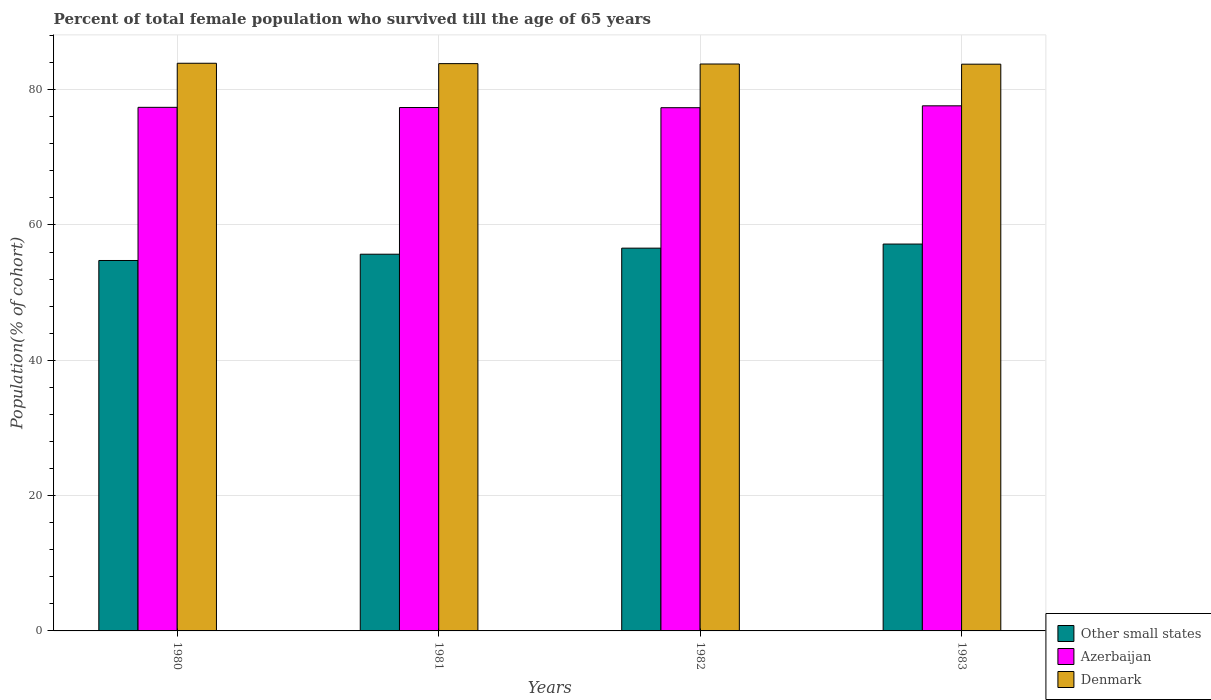How many groups of bars are there?
Ensure brevity in your answer.  4. Are the number of bars per tick equal to the number of legend labels?
Offer a very short reply. Yes. Are the number of bars on each tick of the X-axis equal?
Provide a succinct answer. Yes. How many bars are there on the 2nd tick from the left?
Provide a short and direct response. 3. How many bars are there on the 3rd tick from the right?
Provide a short and direct response. 3. In how many cases, is the number of bars for a given year not equal to the number of legend labels?
Provide a succinct answer. 0. What is the percentage of total female population who survived till the age of 65 years in Azerbaijan in 1982?
Make the answer very short. 77.33. Across all years, what is the maximum percentage of total female population who survived till the age of 65 years in Other small states?
Your answer should be compact. 57.17. Across all years, what is the minimum percentage of total female population who survived till the age of 65 years in Other small states?
Keep it short and to the point. 54.75. What is the total percentage of total female population who survived till the age of 65 years in Other small states in the graph?
Your response must be concise. 224.16. What is the difference between the percentage of total female population who survived till the age of 65 years in Denmark in 1981 and that in 1982?
Provide a succinct answer. 0.05. What is the difference between the percentage of total female population who survived till the age of 65 years in Other small states in 1982 and the percentage of total female population who survived till the age of 65 years in Azerbaijan in 1983?
Your answer should be very brief. -21.03. What is the average percentage of total female population who survived till the age of 65 years in Azerbaijan per year?
Give a very brief answer. 77.42. In the year 1983, what is the difference between the percentage of total female population who survived till the age of 65 years in Azerbaijan and percentage of total female population who survived till the age of 65 years in Denmark?
Your answer should be compact. -6.15. In how many years, is the percentage of total female population who survived till the age of 65 years in Denmark greater than 84 %?
Keep it short and to the point. 0. What is the ratio of the percentage of total female population who survived till the age of 65 years in Azerbaijan in 1980 to that in 1982?
Provide a short and direct response. 1. Is the difference between the percentage of total female population who survived till the age of 65 years in Azerbaijan in 1981 and 1983 greater than the difference between the percentage of total female population who survived till the age of 65 years in Denmark in 1981 and 1983?
Offer a very short reply. No. What is the difference between the highest and the second highest percentage of total female population who survived till the age of 65 years in Azerbaijan?
Your answer should be very brief. 0.22. What is the difference between the highest and the lowest percentage of total female population who survived till the age of 65 years in Azerbaijan?
Provide a short and direct response. 0.28. Is the sum of the percentage of total female population who survived till the age of 65 years in Denmark in 1981 and 1982 greater than the maximum percentage of total female population who survived till the age of 65 years in Azerbaijan across all years?
Offer a very short reply. Yes. What does the 2nd bar from the left in 1980 represents?
Offer a very short reply. Azerbaijan. What does the 1st bar from the right in 1980 represents?
Give a very brief answer. Denmark. Are all the bars in the graph horizontal?
Provide a succinct answer. No. How many years are there in the graph?
Keep it short and to the point. 4. Does the graph contain any zero values?
Your answer should be compact. No. What is the title of the graph?
Ensure brevity in your answer.  Percent of total female population who survived till the age of 65 years. What is the label or title of the Y-axis?
Your answer should be compact. Population(% of cohort). What is the Population(% of cohort) in Other small states in 1980?
Your answer should be very brief. 54.75. What is the Population(% of cohort) in Azerbaijan in 1980?
Give a very brief answer. 77.38. What is the Population(% of cohort) in Denmark in 1980?
Provide a succinct answer. 83.89. What is the Population(% of cohort) in Other small states in 1981?
Your response must be concise. 55.67. What is the Population(% of cohort) of Azerbaijan in 1981?
Provide a succinct answer. 77.35. What is the Population(% of cohort) of Denmark in 1981?
Ensure brevity in your answer.  83.84. What is the Population(% of cohort) in Other small states in 1982?
Your answer should be very brief. 56.57. What is the Population(% of cohort) in Azerbaijan in 1982?
Give a very brief answer. 77.33. What is the Population(% of cohort) of Denmark in 1982?
Your answer should be compact. 83.78. What is the Population(% of cohort) of Other small states in 1983?
Your answer should be very brief. 57.17. What is the Population(% of cohort) in Azerbaijan in 1983?
Your answer should be compact. 77.6. What is the Population(% of cohort) in Denmark in 1983?
Provide a succinct answer. 83.76. Across all years, what is the maximum Population(% of cohort) in Other small states?
Ensure brevity in your answer.  57.17. Across all years, what is the maximum Population(% of cohort) in Azerbaijan?
Offer a very short reply. 77.6. Across all years, what is the maximum Population(% of cohort) of Denmark?
Keep it short and to the point. 83.89. Across all years, what is the minimum Population(% of cohort) in Other small states?
Offer a very short reply. 54.75. Across all years, what is the minimum Population(% of cohort) of Azerbaijan?
Your answer should be compact. 77.33. Across all years, what is the minimum Population(% of cohort) of Denmark?
Your answer should be very brief. 83.76. What is the total Population(% of cohort) in Other small states in the graph?
Offer a terse response. 224.16. What is the total Population(% of cohort) of Azerbaijan in the graph?
Make the answer very short. 309.66. What is the total Population(% of cohort) in Denmark in the graph?
Ensure brevity in your answer.  335.27. What is the difference between the Population(% of cohort) of Other small states in 1980 and that in 1981?
Keep it short and to the point. -0.93. What is the difference between the Population(% of cohort) in Azerbaijan in 1980 and that in 1981?
Offer a very short reply. 0.03. What is the difference between the Population(% of cohort) of Denmark in 1980 and that in 1981?
Offer a very short reply. 0.06. What is the difference between the Population(% of cohort) of Other small states in 1980 and that in 1982?
Provide a short and direct response. -1.82. What is the difference between the Population(% of cohort) in Azerbaijan in 1980 and that in 1982?
Keep it short and to the point. 0.05. What is the difference between the Population(% of cohort) of Denmark in 1980 and that in 1982?
Ensure brevity in your answer.  0.11. What is the difference between the Population(% of cohort) of Other small states in 1980 and that in 1983?
Your answer should be very brief. -2.43. What is the difference between the Population(% of cohort) in Azerbaijan in 1980 and that in 1983?
Keep it short and to the point. -0.22. What is the difference between the Population(% of cohort) in Denmark in 1980 and that in 1983?
Provide a short and direct response. 0.14. What is the difference between the Population(% of cohort) of Other small states in 1981 and that in 1982?
Give a very brief answer. -0.9. What is the difference between the Population(% of cohort) in Azerbaijan in 1981 and that in 1982?
Your answer should be compact. 0.03. What is the difference between the Population(% of cohort) in Denmark in 1981 and that in 1982?
Provide a short and direct response. 0.06. What is the difference between the Population(% of cohort) in Other small states in 1981 and that in 1983?
Give a very brief answer. -1.5. What is the difference between the Population(% of cohort) of Azerbaijan in 1981 and that in 1983?
Your answer should be compact. -0.25. What is the difference between the Population(% of cohort) of Denmark in 1981 and that in 1983?
Your response must be concise. 0.08. What is the difference between the Population(% of cohort) of Other small states in 1982 and that in 1983?
Keep it short and to the point. -0.61. What is the difference between the Population(% of cohort) of Azerbaijan in 1982 and that in 1983?
Keep it short and to the point. -0.28. What is the difference between the Population(% of cohort) of Denmark in 1982 and that in 1983?
Your response must be concise. 0.03. What is the difference between the Population(% of cohort) of Other small states in 1980 and the Population(% of cohort) of Azerbaijan in 1981?
Your response must be concise. -22.61. What is the difference between the Population(% of cohort) in Other small states in 1980 and the Population(% of cohort) in Denmark in 1981?
Provide a succinct answer. -29.09. What is the difference between the Population(% of cohort) of Azerbaijan in 1980 and the Population(% of cohort) of Denmark in 1981?
Keep it short and to the point. -6.46. What is the difference between the Population(% of cohort) of Other small states in 1980 and the Population(% of cohort) of Azerbaijan in 1982?
Provide a succinct answer. -22.58. What is the difference between the Population(% of cohort) in Other small states in 1980 and the Population(% of cohort) in Denmark in 1982?
Make the answer very short. -29.04. What is the difference between the Population(% of cohort) in Azerbaijan in 1980 and the Population(% of cohort) in Denmark in 1982?
Provide a succinct answer. -6.4. What is the difference between the Population(% of cohort) in Other small states in 1980 and the Population(% of cohort) in Azerbaijan in 1983?
Offer a very short reply. -22.86. What is the difference between the Population(% of cohort) in Other small states in 1980 and the Population(% of cohort) in Denmark in 1983?
Keep it short and to the point. -29.01. What is the difference between the Population(% of cohort) of Azerbaijan in 1980 and the Population(% of cohort) of Denmark in 1983?
Offer a very short reply. -6.38. What is the difference between the Population(% of cohort) of Other small states in 1981 and the Population(% of cohort) of Azerbaijan in 1982?
Ensure brevity in your answer.  -21.65. What is the difference between the Population(% of cohort) in Other small states in 1981 and the Population(% of cohort) in Denmark in 1982?
Your answer should be compact. -28.11. What is the difference between the Population(% of cohort) in Azerbaijan in 1981 and the Population(% of cohort) in Denmark in 1982?
Keep it short and to the point. -6.43. What is the difference between the Population(% of cohort) in Other small states in 1981 and the Population(% of cohort) in Azerbaijan in 1983?
Provide a short and direct response. -21.93. What is the difference between the Population(% of cohort) in Other small states in 1981 and the Population(% of cohort) in Denmark in 1983?
Provide a short and direct response. -28.09. What is the difference between the Population(% of cohort) of Azerbaijan in 1981 and the Population(% of cohort) of Denmark in 1983?
Keep it short and to the point. -6.4. What is the difference between the Population(% of cohort) of Other small states in 1982 and the Population(% of cohort) of Azerbaijan in 1983?
Give a very brief answer. -21.03. What is the difference between the Population(% of cohort) in Other small states in 1982 and the Population(% of cohort) in Denmark in 1983?
Make the answer very short. -27.19. What is the difference between the Population(% of cohort) of Azerbaijan in 1982 and the Population(% of cohort) of Denmark in 1983?
Your response must be concise. -6.43. What is the average Population(% of cohort) of Other small states per year?
Your answer should be very brief. 56.04. What is the average Population(% of cohort) of Azerbaijan per year?
Make the answer very short. 77.42. What is the average Population(% of cohort) of Denmark per year?
Offer a very short reply. 83.82. In the year 1980, what is the difference between the Population(% of cohort) in Other small states and Population(% of cohort) in Azerbaijan?
Keep it short and to the point. -22.63. In the year 1980, what is the difference between the Population(% of cohort) in Other small states and Population(% of cohort) in Denmark?
Provide a succinct answer. -29.15. In the year 1980, what is the difference between the Population(% of cohort) in Azerbaijan and Population(% of cohort) in Denmark?
Ensure brevity in your answer.  -6.51. In the year 1981, what is the difference between the Population(% of cohort) in Other small states and Population(% of cohort) in Azerbaijan?
Offer a very short reply. -21.68. In the year 1981, what is the difference between the Population(% of cohort) in Other small states and Population(% of cohort) in Denmark?
Make the answer very short. -28.17. In the year 1981, what is the difference between the Population(% of cohort) in Azerbaijan and Population(% of cohort) in Denmark?
Make the answer very short. -6.49. In the year 1982, what is the difference between the Population(% of cohort) of Other small states and Population(% of cohort) of Azerbaijan?
Your answer should be compact. -20.76. In the year 1982, what is the difference between the Population(% of cohort) in Other small states and Population(% of cohort) in Denmark?
Provide a succinct answer. -27.22. In the year 1982, what is the difference between the Population(% of cohort) of Azerbaijan and Population(% of cohort) of Denmark?
Offer a terse response. -6.46. In the year 1983, what is the difference between the Population(% of cohort) of Other small states and Population(% of cohort) of Azerbaijan?
Offer a very short reply. -20.43. In the year 1983, what is the difference between the Population(% of cohort) of Other small states and Population(% of cohort) of Denmark?
Ensure brevity in your answer.  -26.58. In the year 1983, what is the difference between the Population(% of cohort) in Azerbaijan and Population(% of cohort) in Denmark?
Ensure brevity in your answer.  -6.15. What is the ratio of the Population(% of cohort) of Other small states in 1980 to that in 1981?
Offer a terse response. 0.98. What is the ratio of the Population(% of cohort) in Azerbaijan in 1980 to that in 1981?
Provide a succinct answer. 1. What is the ratio of the Population(% of cohort) of Other small states in 1980 to that in 1982?
Your answer should be compact. 0.97. What is the ratio of the Population(% of cohort) in Azerbaijan in 1980 to that in 1982?
Give a very brief answer. 1. What is the ratio of the Population(% of cohort) in Other small states in 1980 to that in 1983?
Your response must be concise. 0.96. What is the ratio of the Population(% of cohort) of Azerbaijan in 1980 to that in 1983?
Your answer should be compact. 1. What is the ratio of the Population(% of cohort) of Denmark in 1980 to that in 1983?
Your answer should be compact. 1. What is the ratio of the Population(% of cohort) of Other small states in 1981 to that in 1982?
Your answer should be compact. 0.98. What is the ratio of the Population(% of cohort) in Other small states in 1981 to that in 1983?
Your answer should be compact. 0.97. What is the ratio of the Population(% of cohort) of Azerbaijan in 1981 to that in 1983?
Give a very brief answer. 1. What is the ratio of the Population(% of cohort) of Denmark in 1981 to that in 1983?
Ensure brevity in your answer.  1. What is the ratio of the Population(% of cohort) of Other small states in 1982 to that in 1983?
Provide a succinct answer. 0.99. What is the ratio of the Population(% of cohort) in Denmark in 1982 to that in 1983?
Provide a succinct answer. 1. What is the difference between the highest and the second highest Population(% of cohort) in Other small states?
Your answer should be very brief. 0.61. What is the difference between the highest and the second highest Population(% of cohort) in Azerbaijan?
Your answer should be compact. 0.22. What is the difference between the highest and the second highest Population(% of cohort) of Denmark?
Make the answer very short. 0.06. What is the difference between the highest and the lowest Population(% of cohort) of Other small states?
Give a very brief answer. 2.43. What is the difference between the highest and the lowest Population(% of cohort) of Azerbaijan?
Offer a terse response. 0.28. What is the difference between the highest and the lowest Population(% of cohort) in Denmark?
Ensure brevity in your answer.  0.14. 